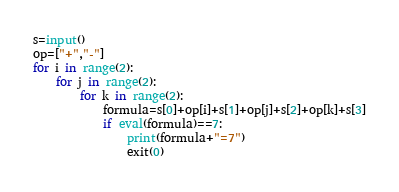Convert code to text. <code><loc_0><loc_0><loc_500><loc_500><_Python_>s=input()
op=["+","-"]
for i in range(2):
    for j in range(2):
        for k in range(2):
            formula=s[0]+op[i]+s[1]+op[j]+s[2]+op[k]+s[3]
            if eval(formula)==7:
                print(formula+"=7")
                exit(0)</code> 